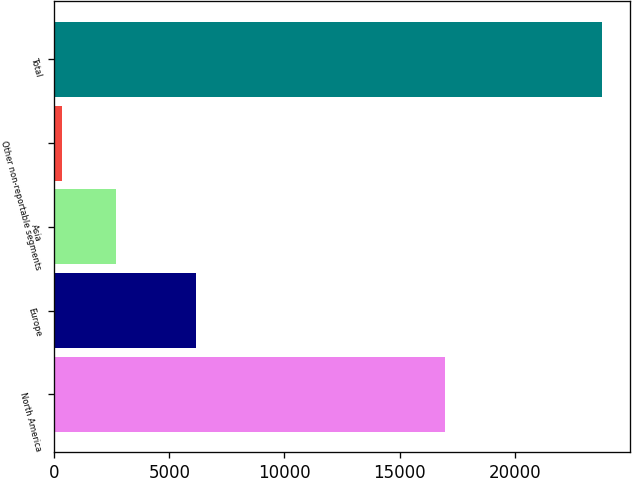<chart> <loc_0><loc_0><loc_500><loc_500><bar_chart><fcel>North America<fcel>Europe<fcel>Asia<fcel>Other non-reportable segments<fcel>Total<nl><fcel>16970<fcel>6164<fcel>2678.3<fcel>331<fcel>23804<nl></chart> 